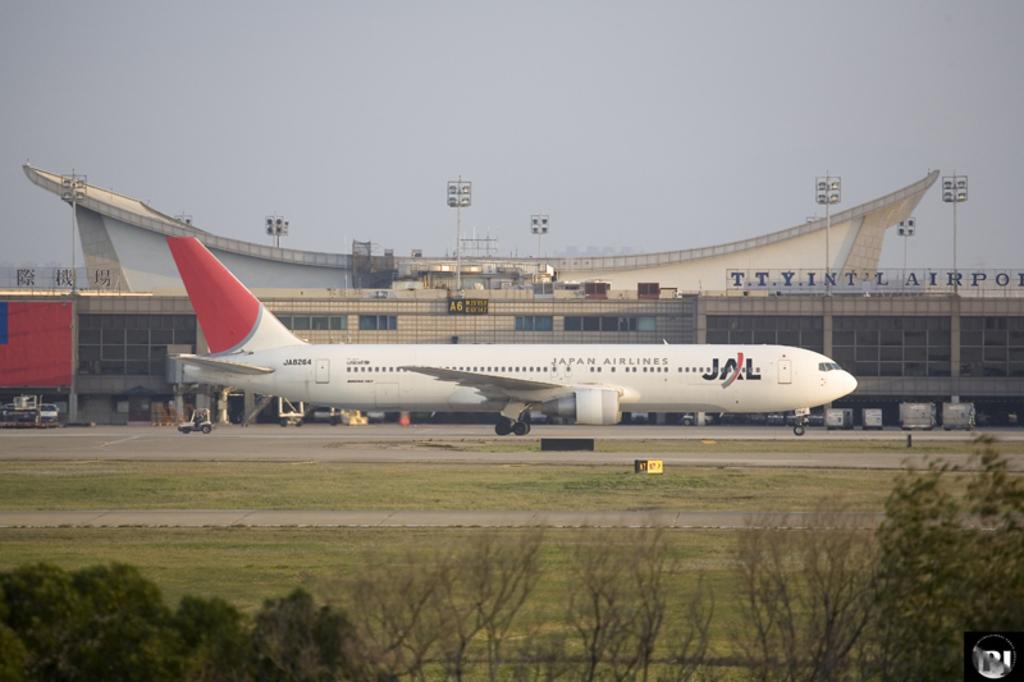What is the name of the airline?
Your answer should be compact. Jal. Which airport was this?
Give a very brief answer. Tty. 